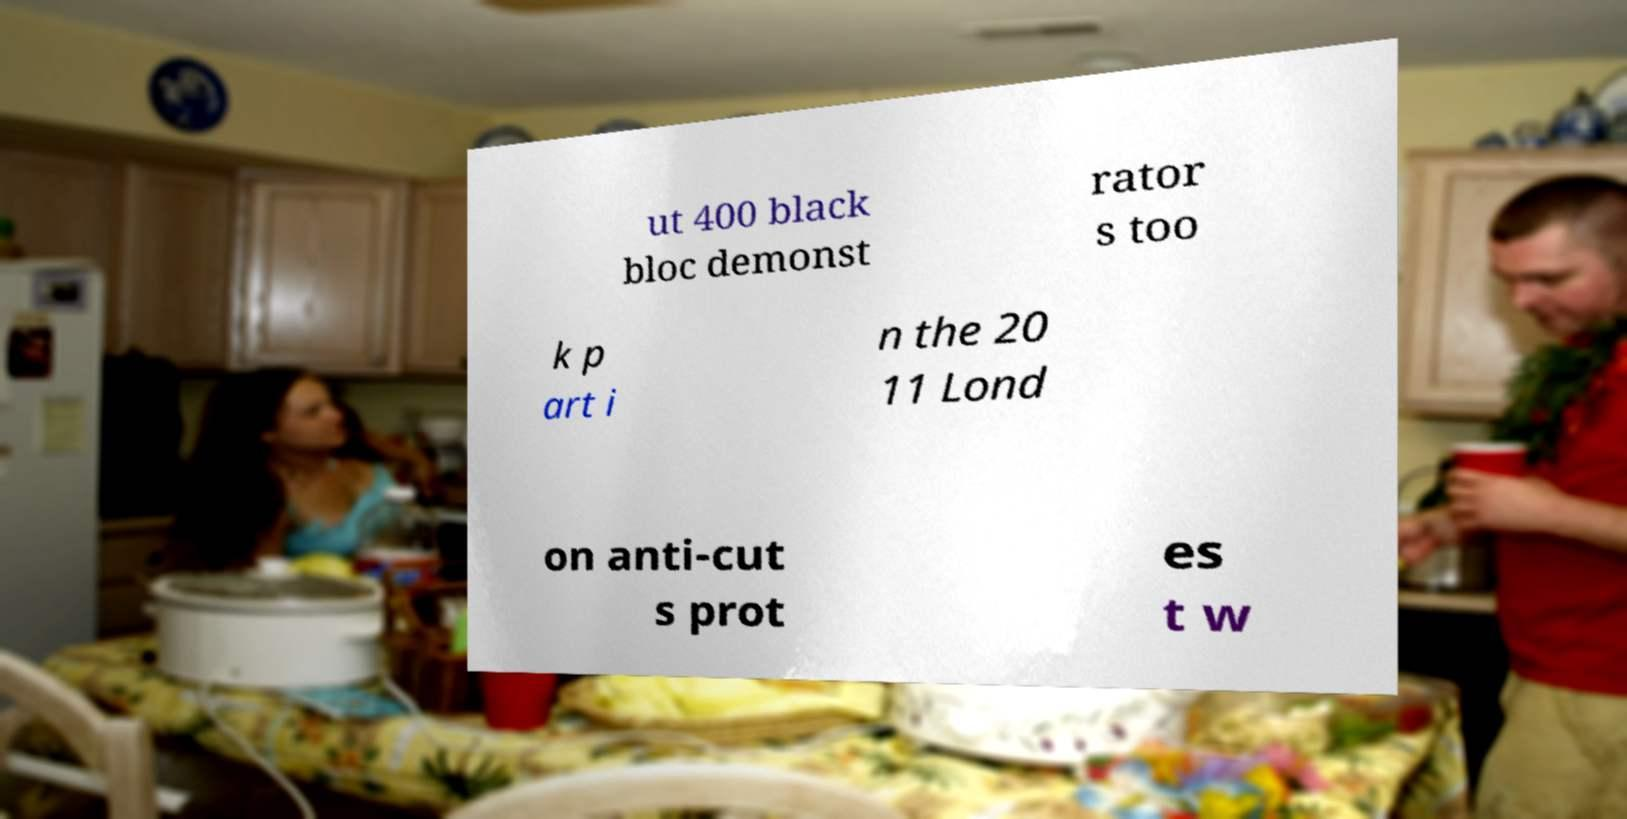Please read and relay the text visible in this image. What does it say? ut 400 black bloc demonst rator s too k p art i n the 20 11 Lond on anti-cut s prot es t w 